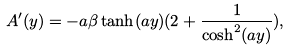<formula> <loc_0><loc_0><loc_500><loc_500>A ^ { \prime } ( y ) = - a \beta \tanh ( a y ) ( 2 + \frac { 1 } { \cosh ^ { 2 } ( a y ) } ) ,</formula> 